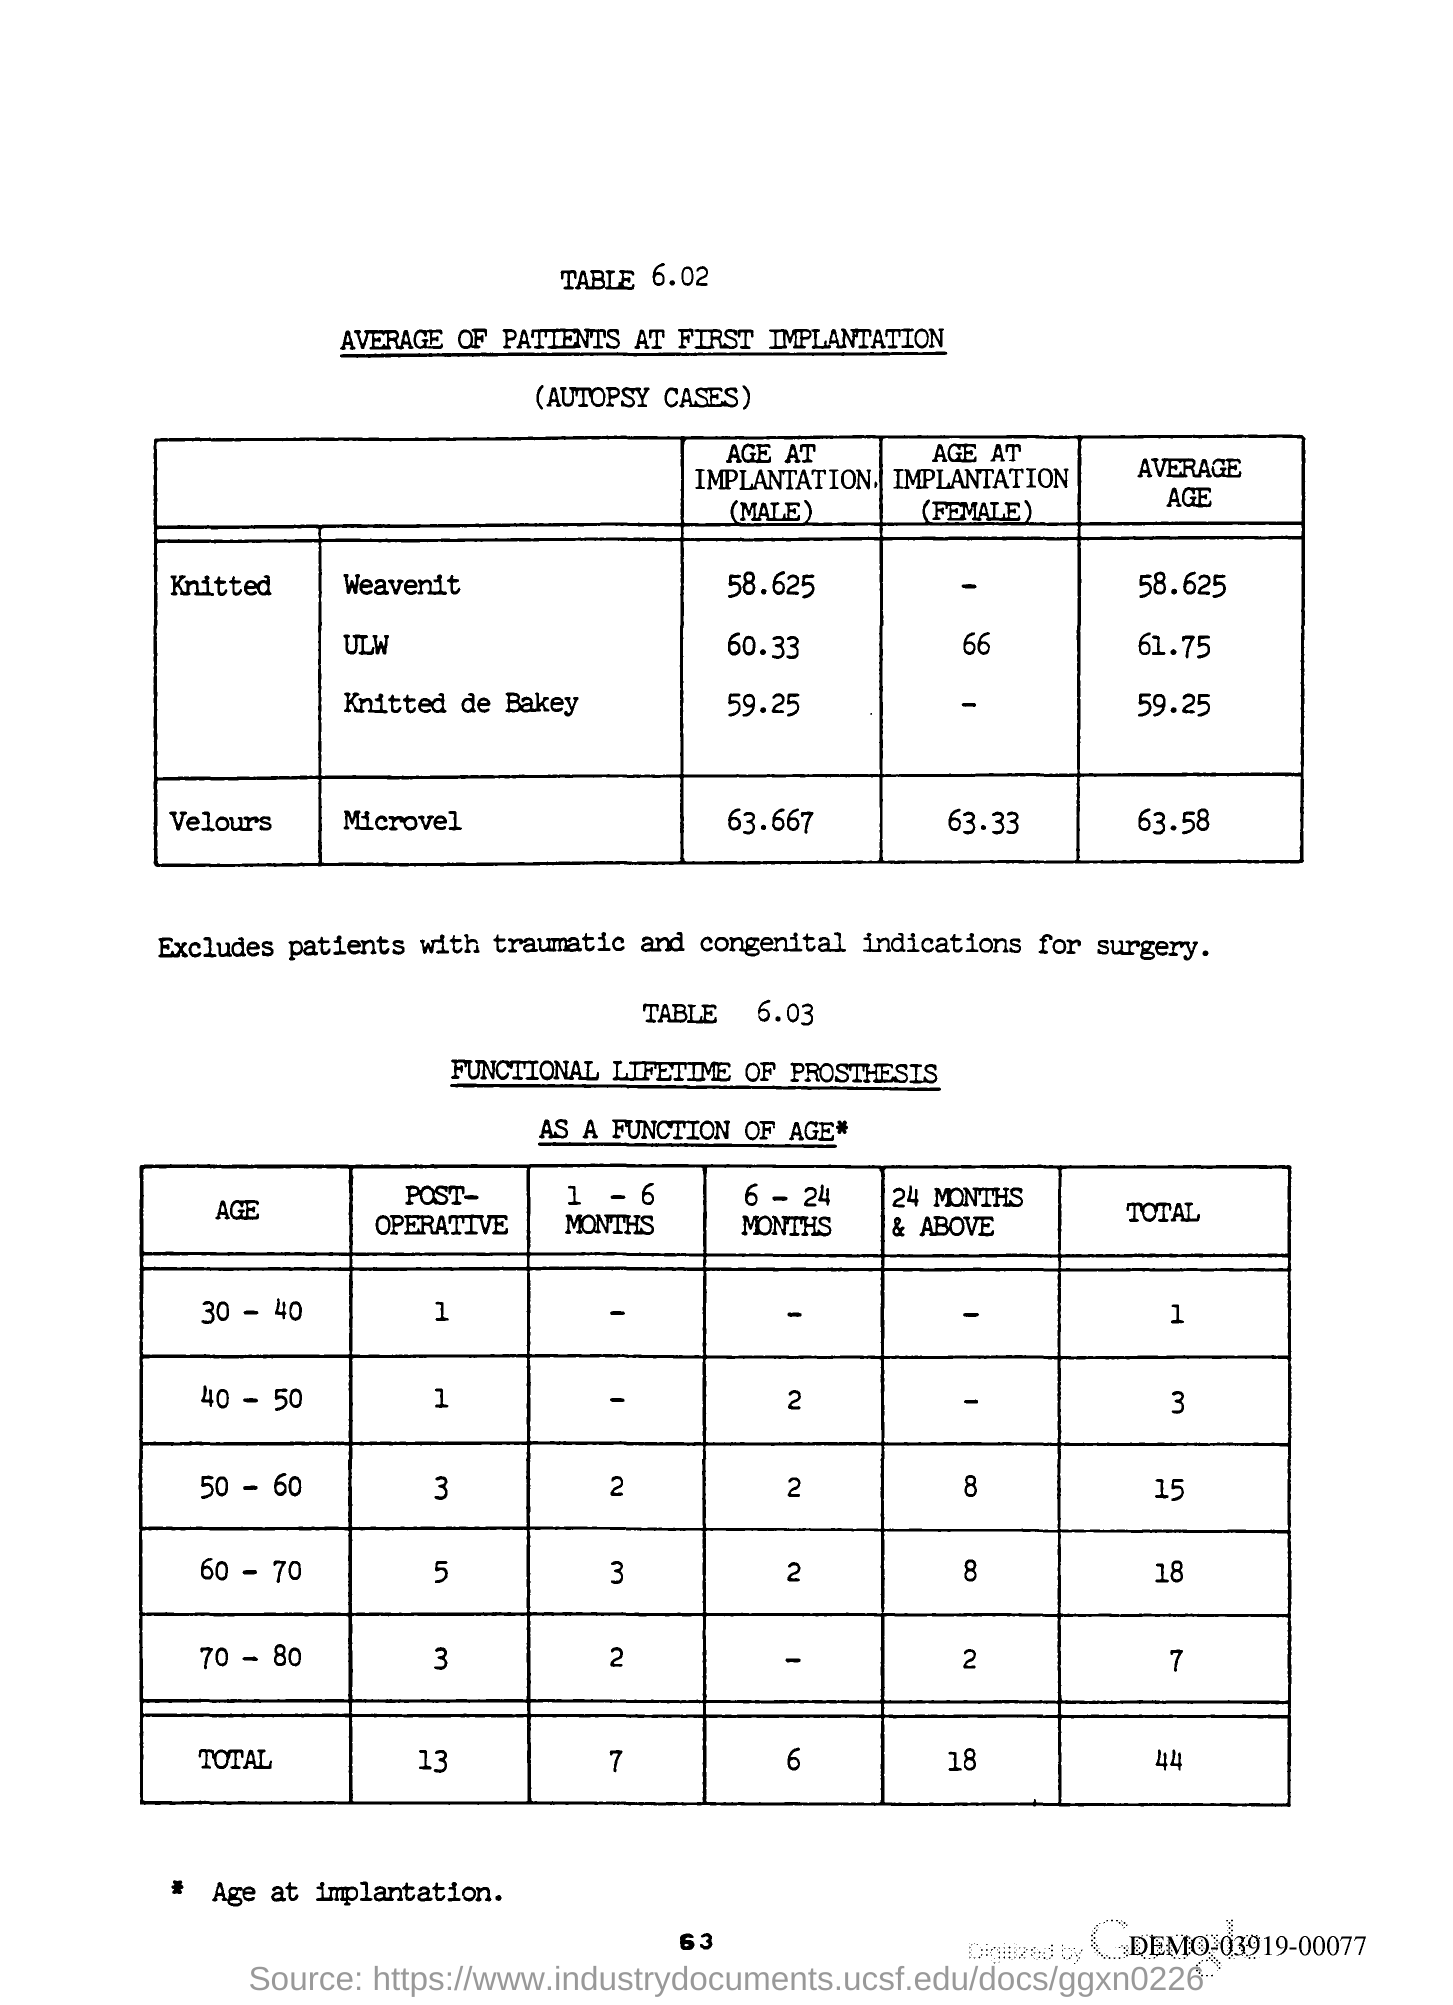What is the Page Number?
Your answer should be very brief. 63. 